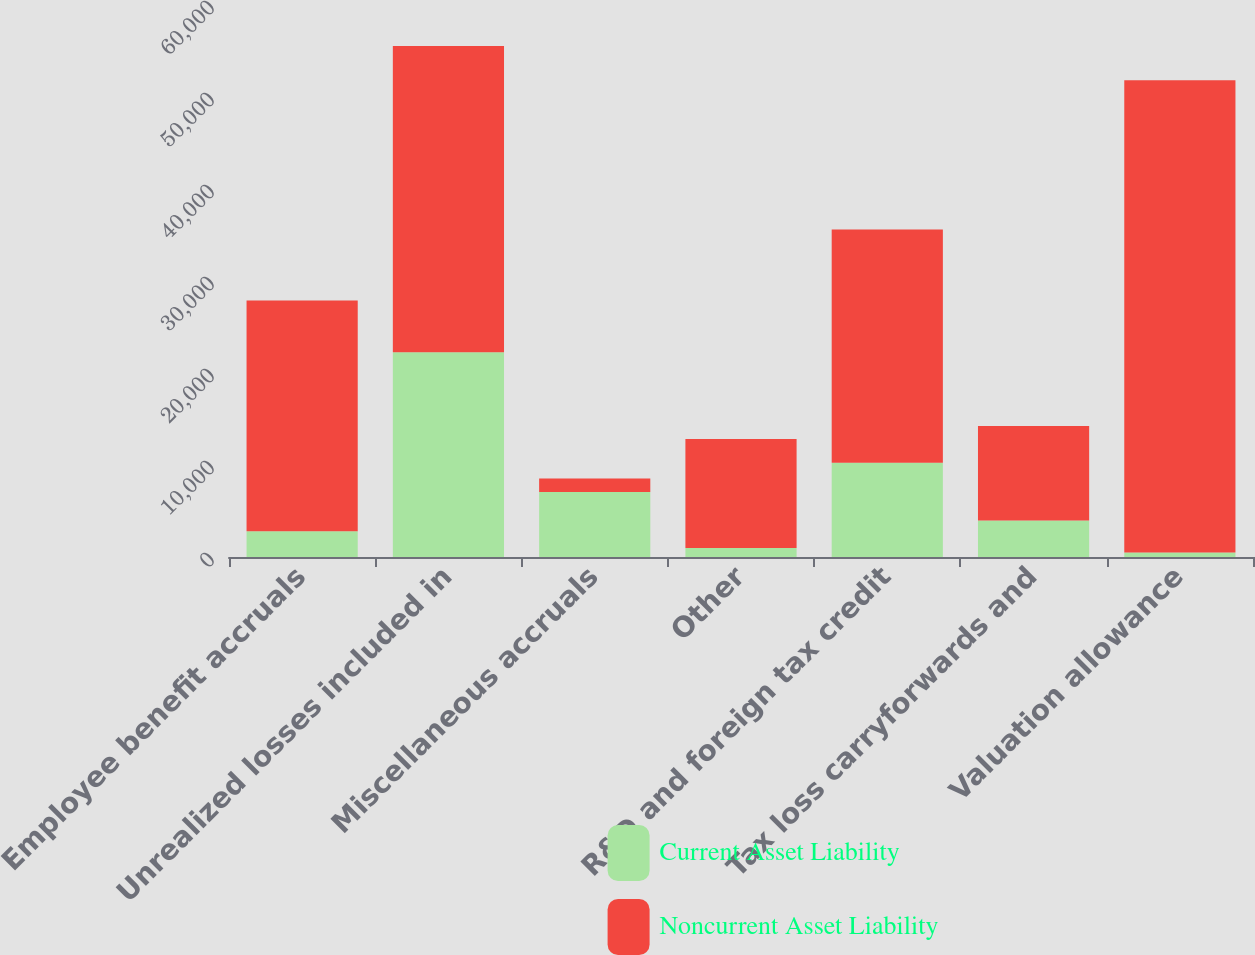Convert chart. <chart><loc_0><loc_0><loc_500><loc_500><stacked_bar_chart><ecel><fcel>Employee benefit accruals<fcel>Unrealized losses included in<fcel>Miscellaneous accruals<fcel>Other<fcel>R&D and foreign tax credit<fcel>Tax loss carryforwards and<fcel>Valuation allowance<nl><fcel>Current Asset Liability<fcel>2791<fcel>22249<fcel>7072<fcel>974<fcel>10254<fcel>3979<fcel>485<nl><fcel>Noncurrent Asset Liability<fcel>25085<fcel>33296<fcel>1457<fcel>11853<fcel>25355<fcel>10254<fcel>51324<nl></chart> 